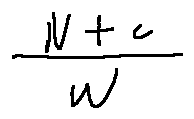Convert formula to latex. <formula><loc_0><loc_0><loc_500><loc_500>\frac { N + c } { w }</formula> 